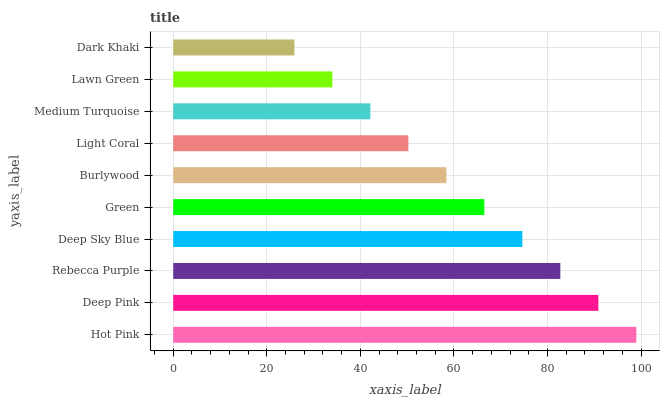Is Dark Khaki the minimum?
Answer yes or no. Yes. Is Hot Pink the maximum?
Answer yes or no. Yes. Is Deep Pink the minimum?
Answer yes or no. No. Is Deep Pink the maximum?
Answer yes or no. No. Is Hot Pink greater than Deep Pink?
Answer yes or no. Yes. Is Deep Pink less than Hot Pink?
Answer yes or no. Yes. Is Deep Pink greater than Hot Pink?
Answer yes or no. No. Is Hot Pink less than Deep Pink?
Answer yes or no. No. Is Green the high median?
Answer yes or no. Yes. Is Burlywood the low median?
Answer yes or no. Yes. Is Dark Khaki the high median?
Answer yes or no. No. Is Light Coral the low median?
Answer yes or no. No. 